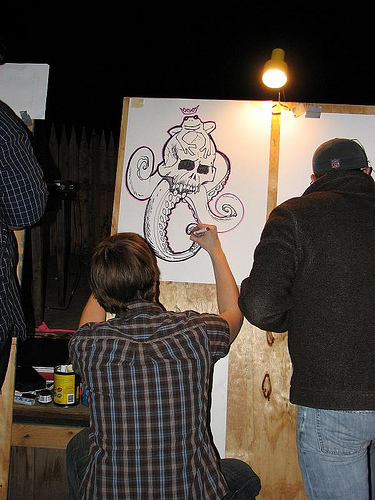<image>
Is there a man to the left of the man? Yes. From this viewpoint, the man is positioned to the left side relative to the man. Where is the drawing in relation to the artist? Is it above the artist? No. The drawing is not positioned above the artist. The vertical arrangement shows a different relationship. 